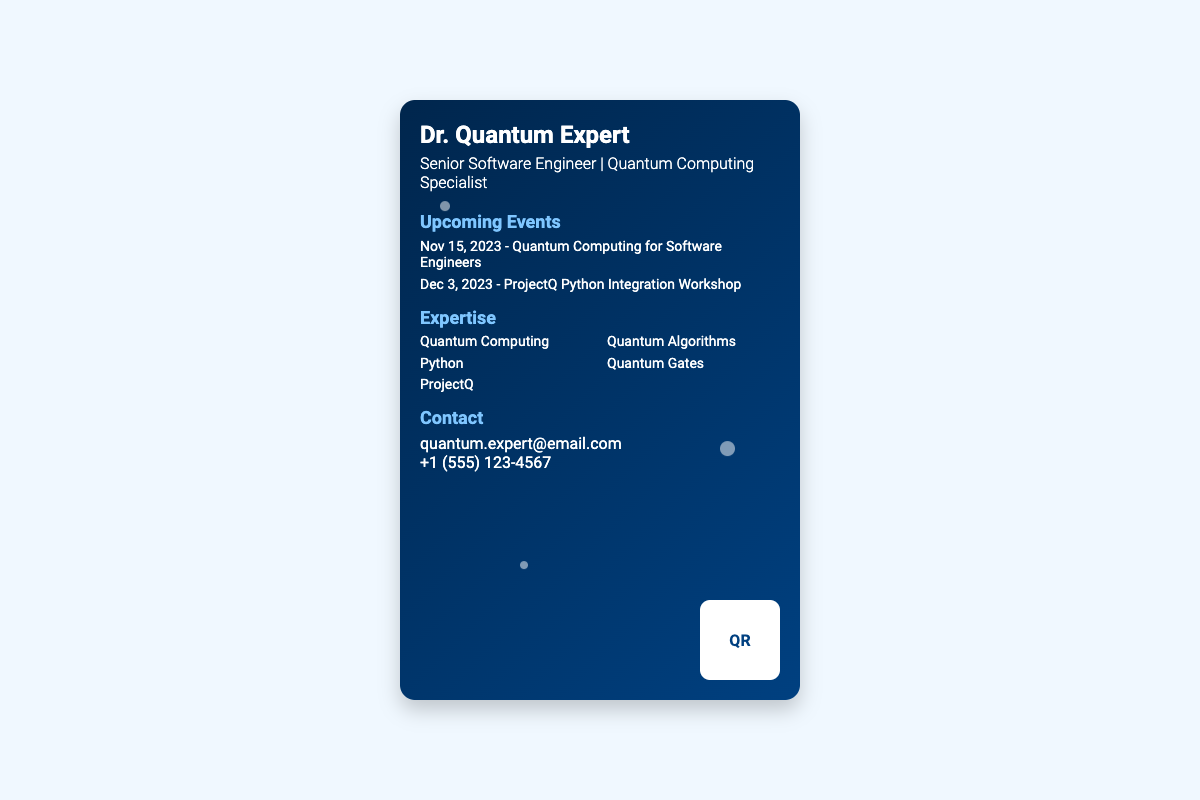What is the name of the expert? The expert's name is displayed at the top of the business card.
Answer: Dr. Quantum Expert What is the date of the upcoming seminar on Quantum Computing? The date is specified under the Upcoming Events section.
Answer: Nov 15, 2023 What workshop is scheduled for December? The workshop title is listed in the Upcoming Events section as well.
Answer: ProjectQ Python Integration Workshop What is the main focus of the expertise listed on the card? The card lists multiple areas of expertise, with a notable one.
Answer: Quantum Computing What is the contact email provided? The email address is shown in the Contact section.
Answer: quantum.expert@email.com How many topics are covered under expertise? The topics are listed in a column format, and there are multiple entries.
Answer: Five What color scheme is used on the business card? The background and text colors are visible and consistent throughout.
Answer: Gradient of blue Where is the QR code located on the card? The QR code's position is described in the design of the card.
Answer: Bottom right 